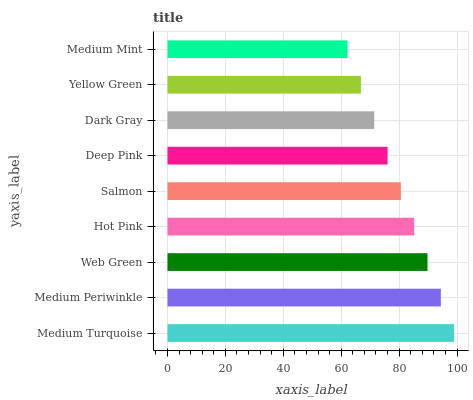Is Medium Mint the minimum?
Answer yes or no. Yes. Is Medium Turquoise the maximum?
Answer yes or no. Yes. Is Medium Periwinkle the minimum?
Answer yes or no. No. Is Medium Periwinkle the maximum?
Answer yes or no. No. Is Medium Turquoise greater than Medium Periwinkle?
Answer yes or no. Yes. Is Medium Periwinkle less than Medium Turquoise?
Answer yes or no. Yes. Is Medium Periwinkle greater than Medium Turquoise?
Answer yes or no. No. Is Medium Turquoise less than Medium Periwinkle?
Answer yes or no. No. Is Salmon the high median?
Answer yes or no. Yes. Is Salmon the low median?
Answer yes or no. Yes. Is Medium Turquoise the high median?
Answer yes or no. No. Is Medium Mint the low median?
Answer yes or no. No. 